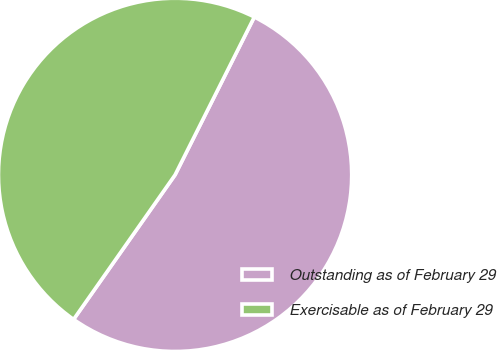Convert chart. <chart><loc_0><loc_0><loc_500><loc_500><pie_chart><fcel>Outstanding as of February 29<fcel>Exercisable as of February 29<nl><fcel>52.34%<fcel>47.66%<nl></chart> 